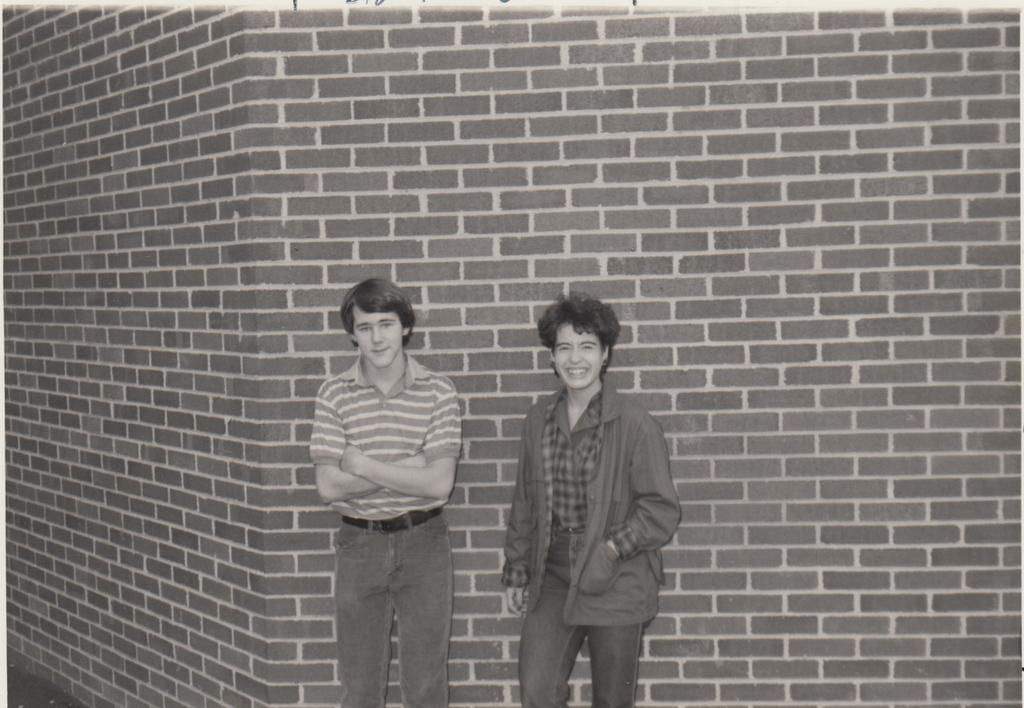How many people are in the image? There are two persons in the image. What are the two persons doing in the image? The two persons are standing and posing for a photograph. What can be seen in the background of the image? There is a brick wall in the background of the image. What type of knowledge is the earth gaining from the photograph in the image? There is no indication in the image that the earth is gaining any knowledge from the photograph. 